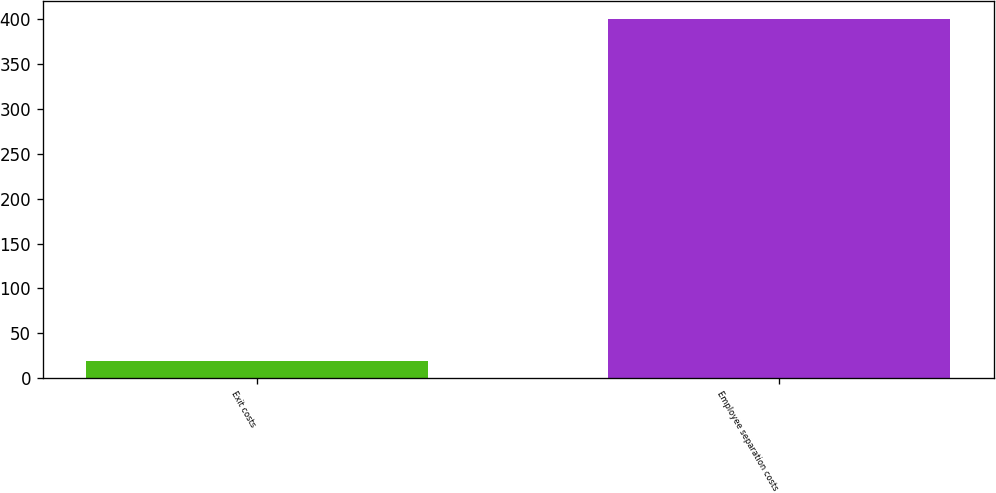Convert chart to OTSL. <chart><loc_0><loc_0><loc_500><loc_500><bar_chart><fcel>Exit costs<fcel>Employee separation costs<nl><fcel>19<fcel>401<nl></chart> 